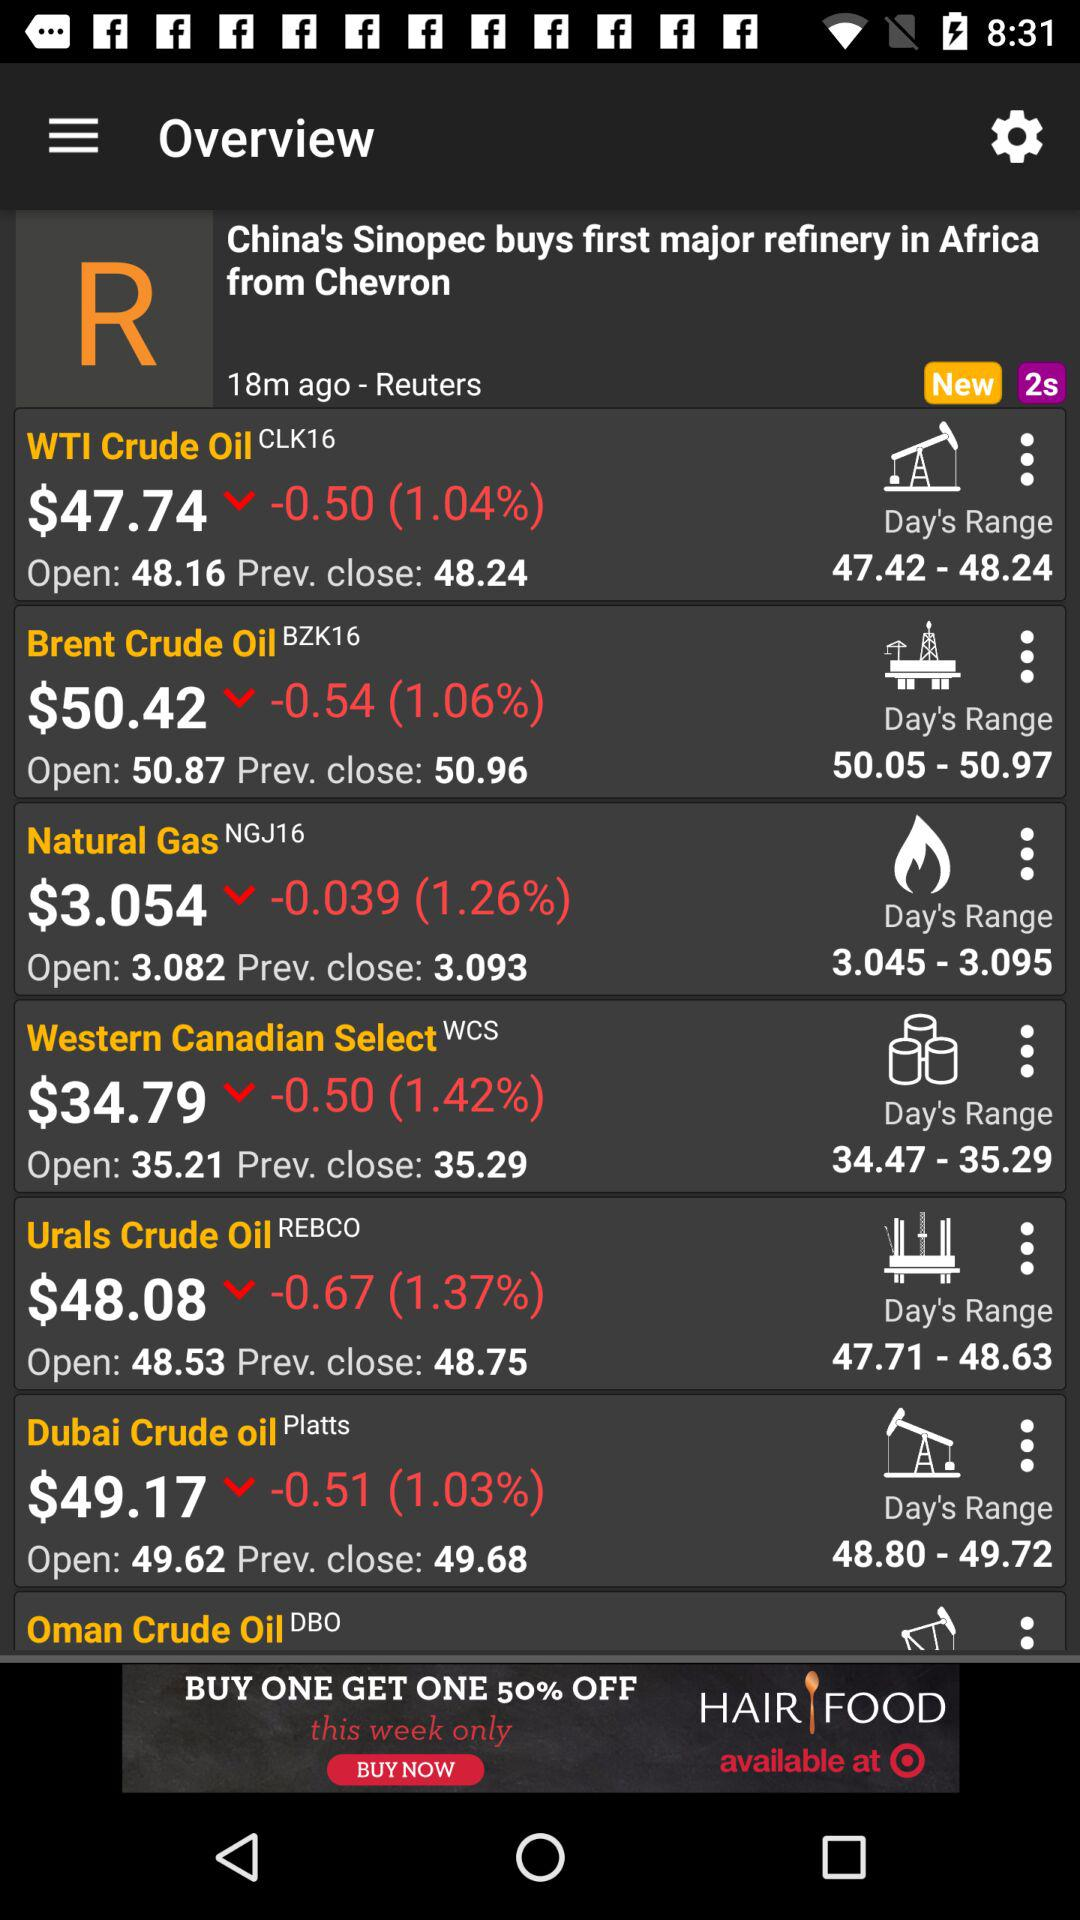What is the price in dollars of "WTI Crude Oil"? The price of "WTI Crude Oil" is $47.74. 